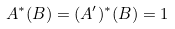Convert formula to latex. <formula><loc_0><loc_0><loc_500><loc_500>A ^ { * } ( B ) = ( A ^ { \prime } ) ^ { * } ( B ) = 1</formula> 